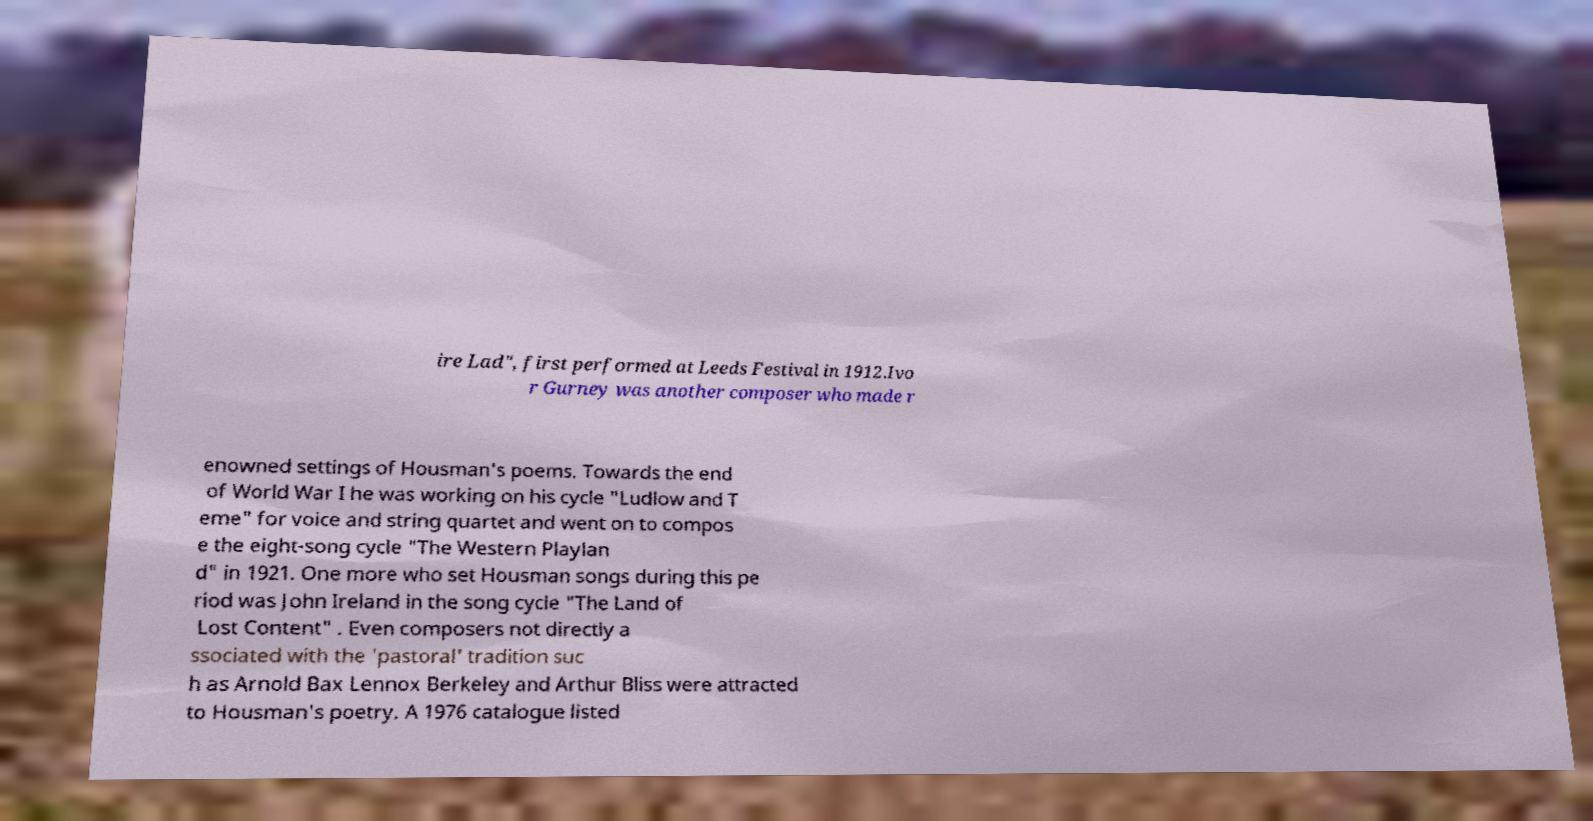What messages or text are displayed in this image? I need them in a readable, typed format. ire Lad", first performed at Leeds Festival in 1912.Ivo r Gurney was another composer who made r enowned settings of Housman's poems. Towards the end of World War I he was working on his cycle "Ludlow and T eme" for voice and string quartet and went on to compos e the eight-song cycle "The Western Playlan d" in 1921. One more who set Housman songs during this pe riod was John Ireland in the song cycle "The Land of Lost Content" . Even composers not directly a ssociated with the 'pastoral' tradition suc h as Arnold Bax Lennox Berkeley and Arthur Bliss were attracted to Housman's poetry. A 1976 catalogue listed 